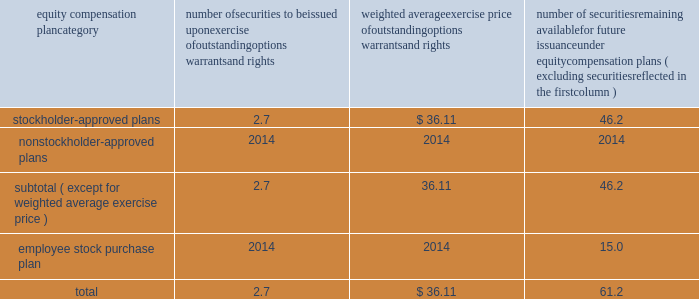Bhge 2018 form 10-k | 107 part iii item 10 .
Directors , executive officers and corporate governance information regarding our code of conduct , the spirit and the letter , and code of ethical conduct certificates for our principal executive officer , principal financial officer and principal accounting officer are described in item 1 .
Business of this annual report .
Information concerning our directors is set forth in the sections entitled "proposal no .
1 , election of directors - board nominees for directors" and "corporate governance - committees of the board" in our definitive proxy statement for the 2019 annual meeting of stockholders to be filed with the sec pursuant to the exchange act within 120 days of the end of our fiscal year on december 31 , 2018 ( proxy statement ) , which sections are incorporated herein by reference .
For information regarding our executive officers , see "item 1 .
Business - executive officers of baker hughes" in this annual report on form 10-k .
Additional information regarding compliance by directors and executive officers with section 16 ( a ) of the exchange act is set forth under the section entitled "section 16 ( a ) beneficial ownership reporting compliance" in our proxy statement , which section is incorporated herein by reference .
Item 11 .
Executive compensation information for this item is set forth in the following sections of our proxy statement , which sections are incorporated herein by reference : "compensation discussion and analysis" "director compensation" "compensation committee interlocks and insider participation" and "compensation committee report." item 12 .
Security ownership of certain beneficial owners and management and related stockholder matters information concerning security ownership of certain beneficial owners and our management is set forth in the sections entitled "stock ownership of certain beneficial owners" and 201cstock ownership of section 16 ( a ) director and executive officers 201d in our proxy statement , which sections are incorporated herein by reference .
We permit our employees , officers and directors to enter into written trading plans complying with rule 10b5-1 under the exchange act .
Rule 10b5-1 provides criteria under which such an individual may establish a prearranged plan to buy or sell a specified number of shares of a company's stock over a set period of time .
Any such plan must be entered into in good faith at a time when the individual is not in possession of material , nonpublic information .
If an individual establishes a plan satisfying the requirements of rule 10b5-1 , such individual's subsequent receipt of material , nonpublic information will not prevent transactions under the plan from being executed .
Certain of our officers have advised us that they have and may enter into stock sales plans for the sale of shares of our class a common stock which are intended to comply with the requirements of rule 10b5-1 of the exchange act .
In addition , the company has and may in the future enter into repurchases of our class a common stock under a plan that complies with rule 10b5-1 or rule 10b-18 of the exchange act .
Equity compensation plan information the information in the table is presented as of december 31 , 2018 with respect to shares of our class a common stock that may be issued under our lti plan which has been approved by our stockholders ( in millions , except per share prices ) .
Equity compensation plan category number of securities to be issued upon exercise of outstanding options , warrants and rights weighted average exercise price of outstanding options , warrants and rights number of securities remaining available for future issuance under equity compensation plans ( excluding securities reflected in the first column ) .

What is the employee stock purchase plan as a percentage of the total number of securities available for future issuance under equity compensation plans? 
Computations: (15.0 / 61.2)
Answer: 0.2451. 